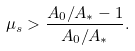<formula> <loc_0><loc_0><loc_500><loc_500>\mu _ { s } > \frac { A _ { 0 } / A _ { * } - 1 } { A _ { 0 } / A _ { * } } .</formula> 